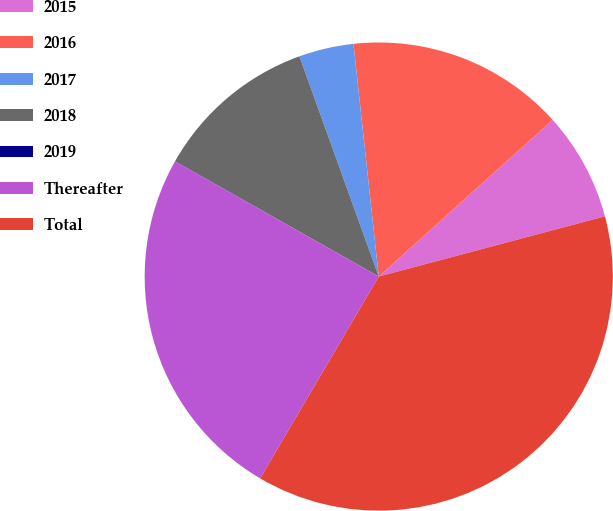<chart> <loc_0><loc_0><loc_500><loc_500><pie_chart><fcel>2015<fcel>2016<fcel>2017<fcel>2018<fcel>2019<fcel>Thereafter<fcel>Total<nl><fcel>7.53%<fcel>15.05%<fcel>3.78%<fcel>11.29%<fcel>0.02%<fcel>24.73%<fcel>37.6%<nl></chart> 